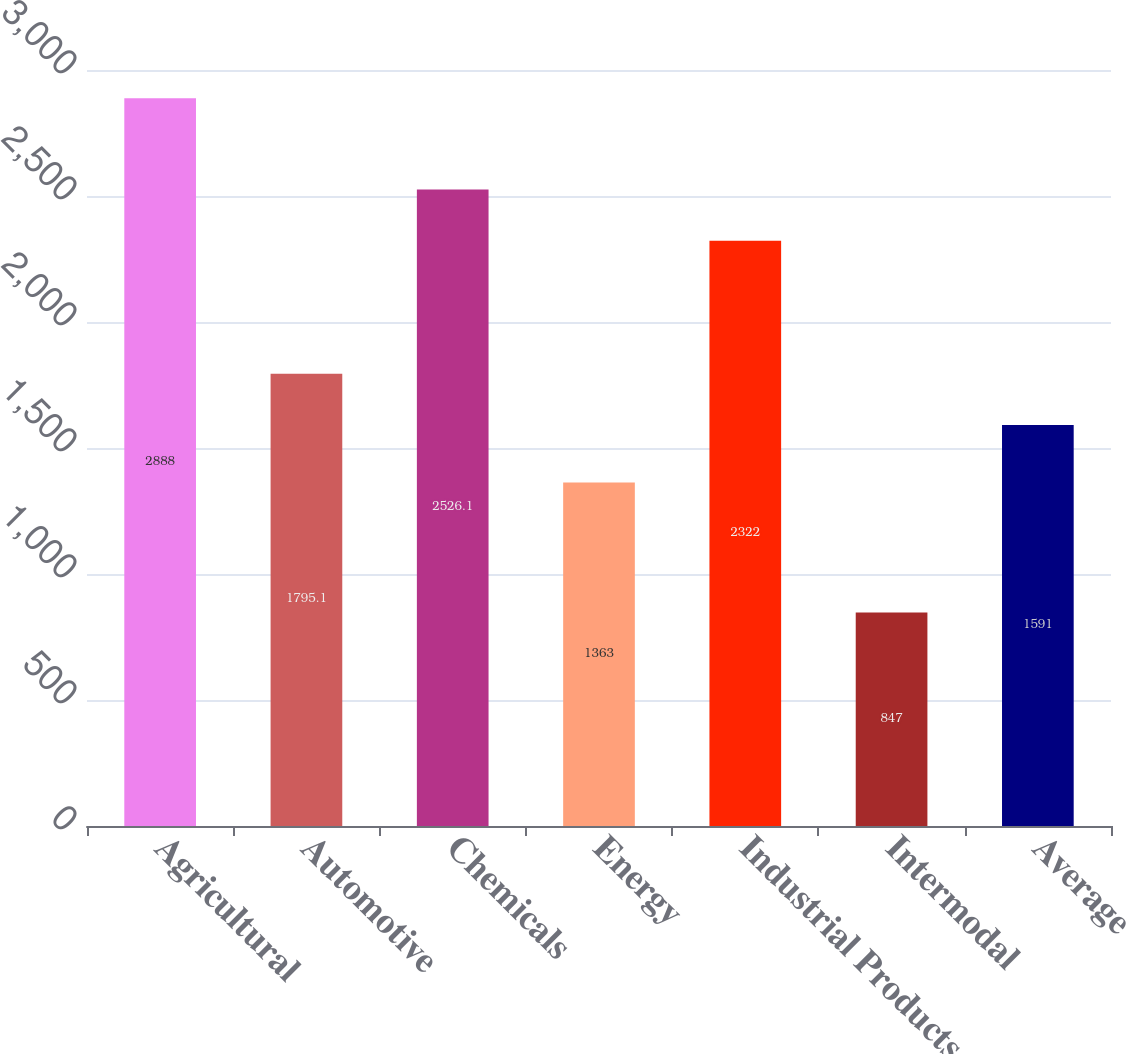<chart> <loc_0><loc_0><loc_500><loc_500><bar_chart><fcel>Agricultural<fcel>Automotive<fcel>Chemicals<fcel>Energy<fcel>Industrial Products<fcel>Intermodal<fcel>Average<nl><fcel>2888<fcel>1795.1<fcel>2526.1<fcel>1363<fcel>2322<fcel>847<fcel>1591<nl></chart> 